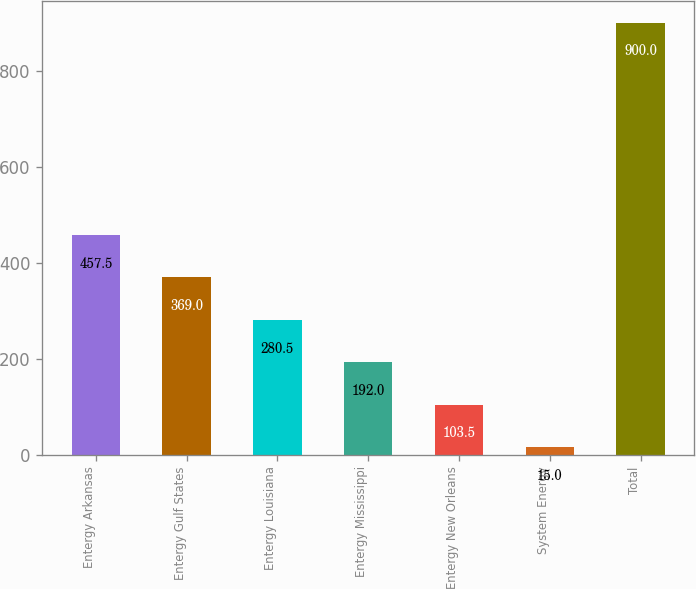<chart> <loc_0><loc_0><loc_500><loc_500><bar_chart><fcel>Entergy Arkansas<fcel>Entergy Gulf States<fcel>Entergy Louisiana<fcel>Entergy Mississippi<fcel>Entergy New Orleans<fcel>System Energy<fcel>Total<nl><fcel>457.5<fcel>369<fcel>280.5<fcel>192<fcel>103.5<fcel>15<fcel>900<nl></chart> 